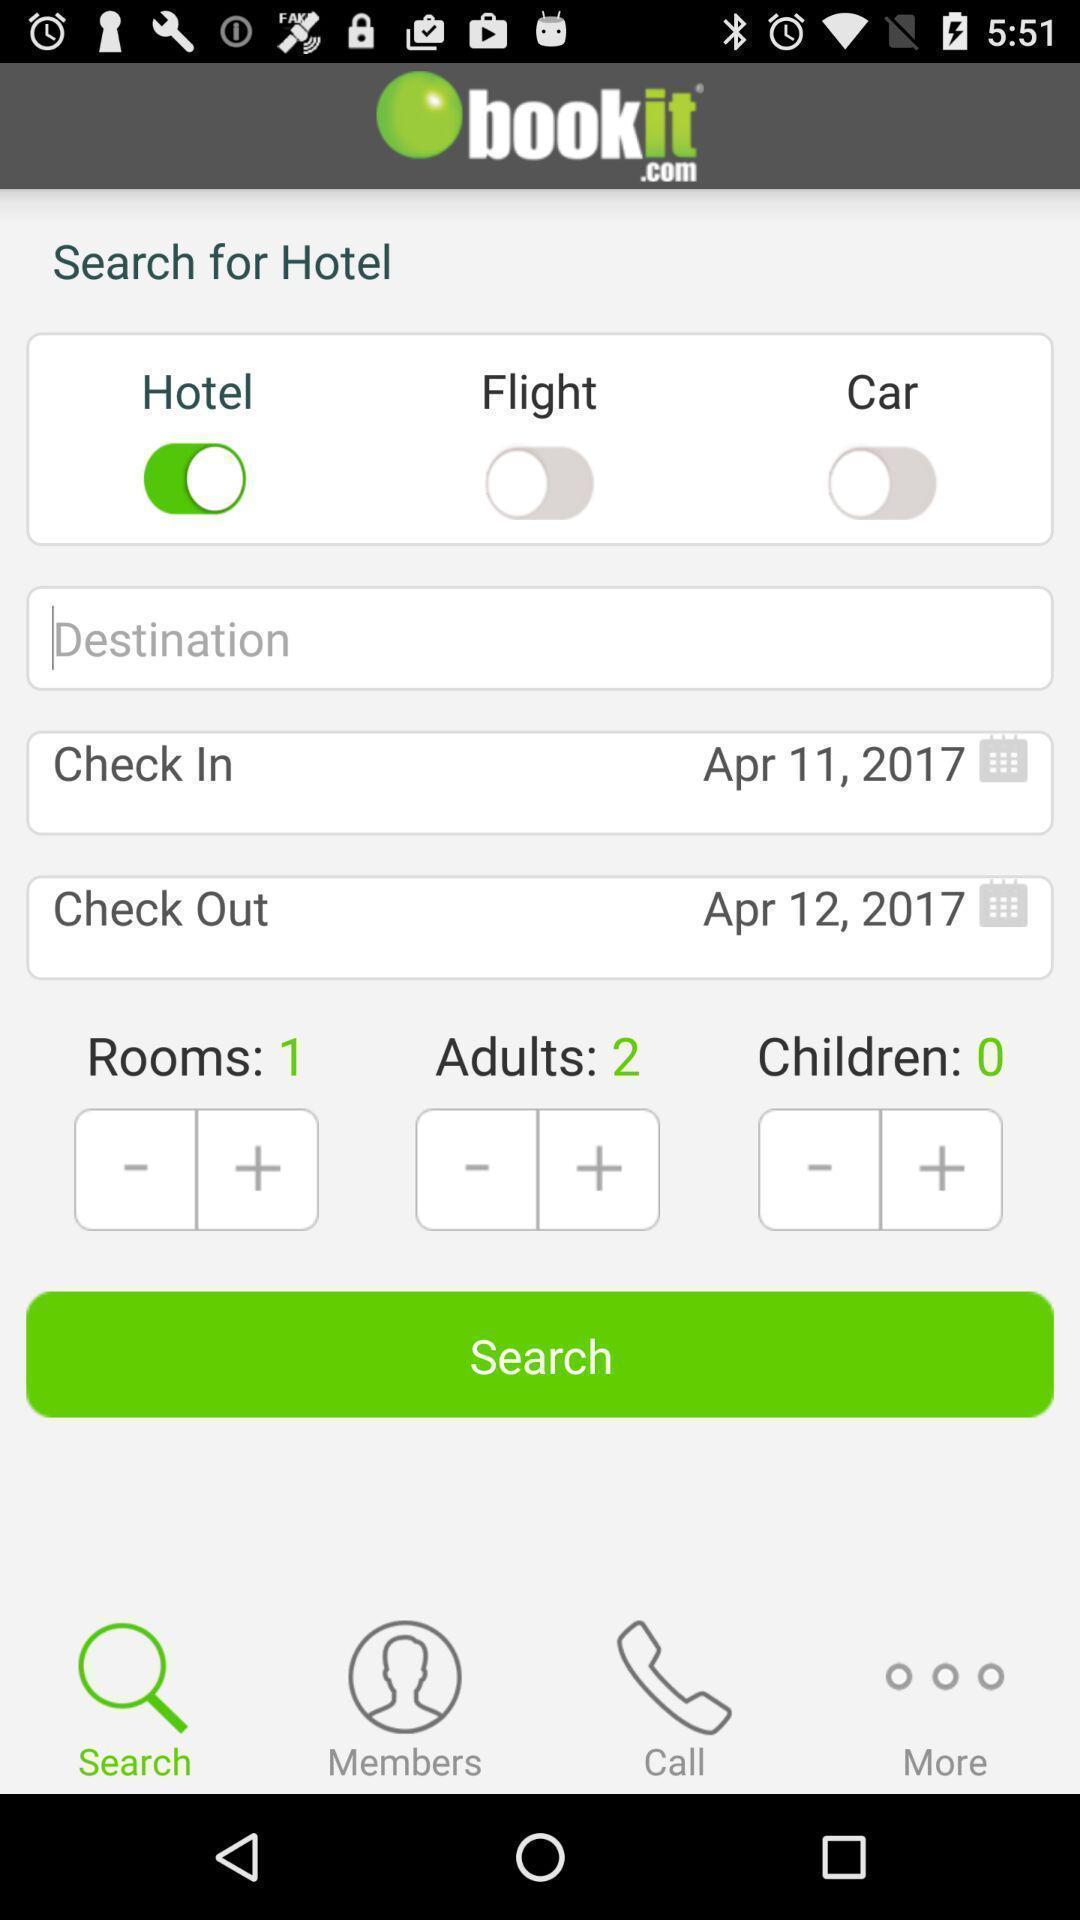Describe the visual elements of this screenshot. Search page for searching a hotel for booking. 